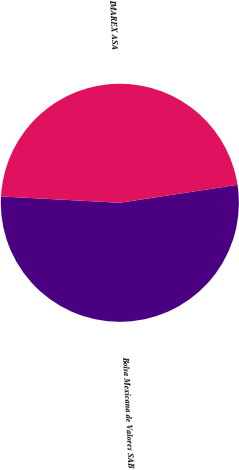Convert chart. <chart><loc_0><loc_0><loc_500><loc_500><pie_chart><fcel>Bolsa Mexicana de Valores SAB<fcel>IMAREX ASA<nl><fcel>53.26%<fcel>46.74%<nl></chart> 